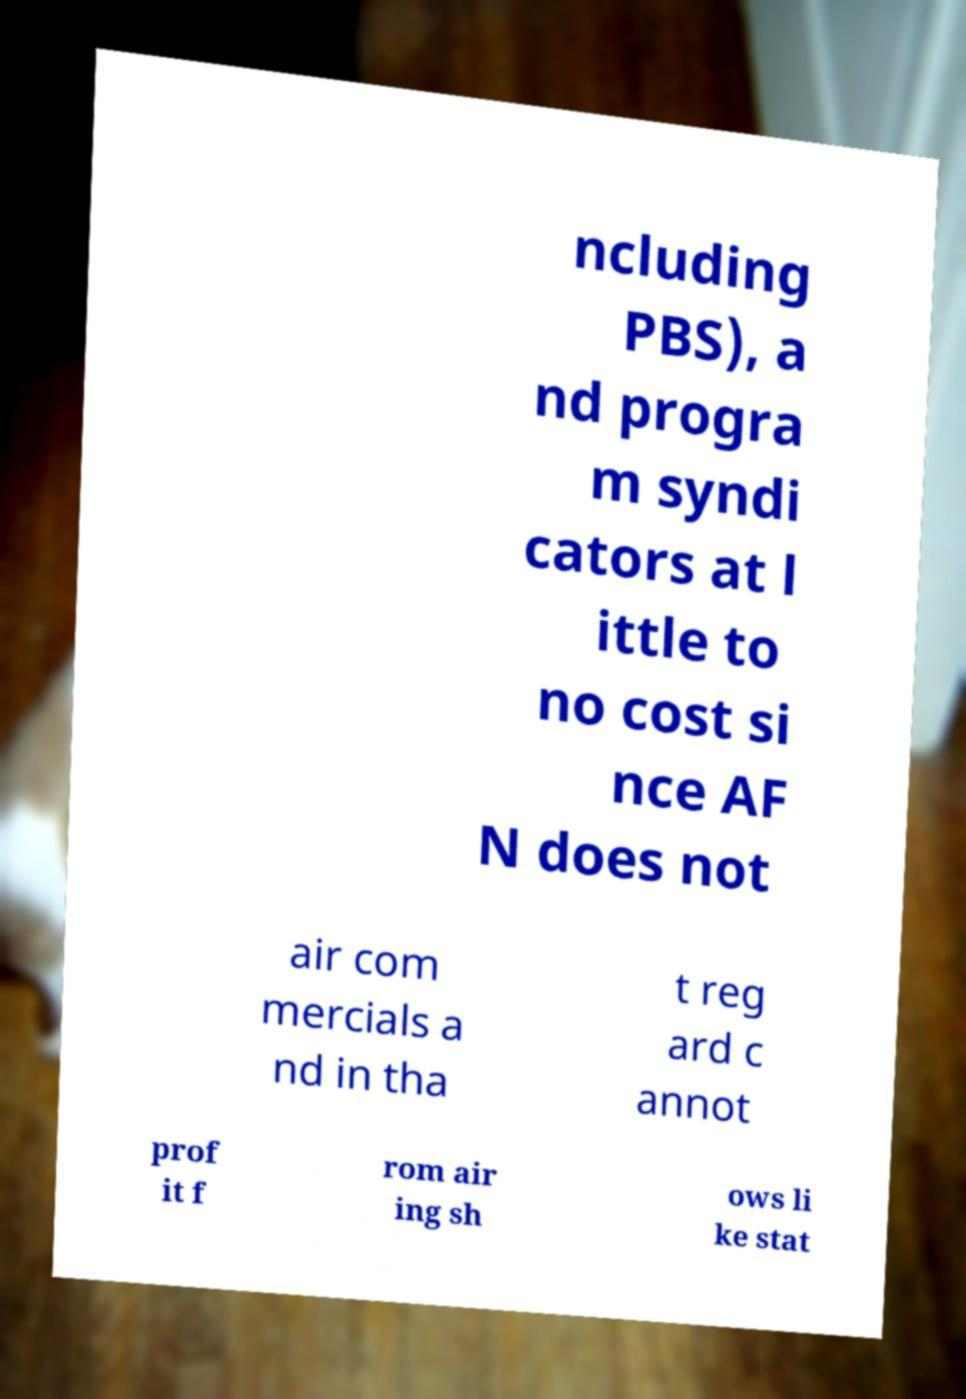Please identify and transcribe the text found in this image. ncluding PBS), a nd progra m syndi cators at l ittle to no cost si nce AF N does not air com mercials a nd in tha t reg ard c annot prof it f rom air ing sh ows li ke stat 